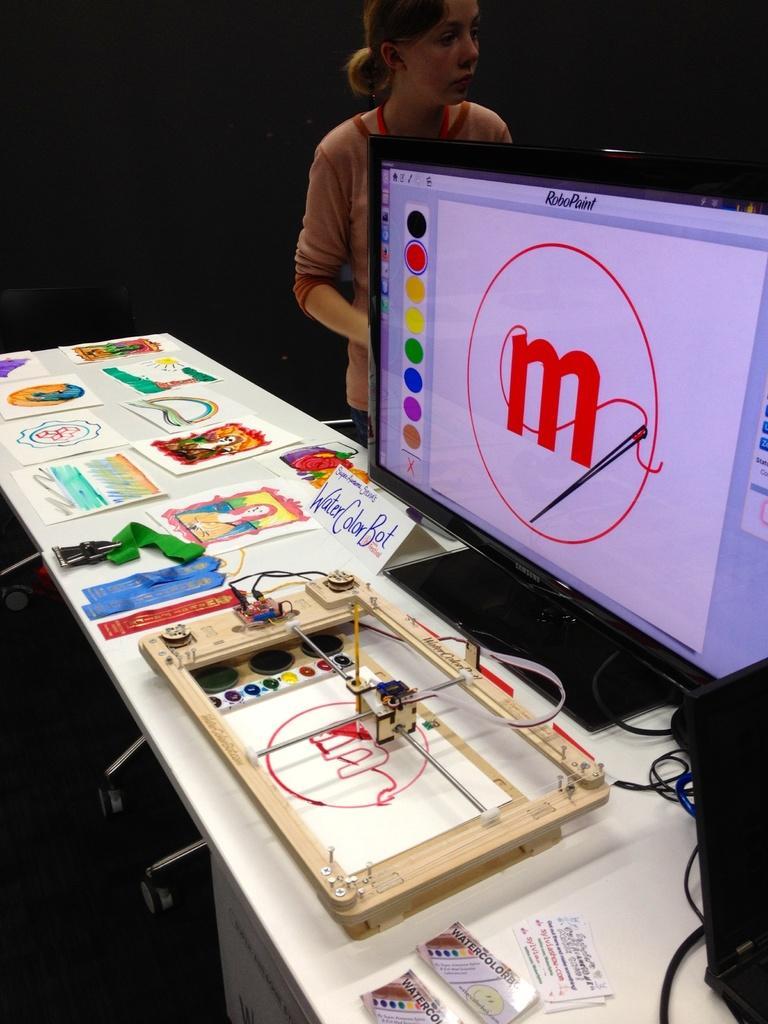Could you give a brief overview of what you see in this image? In this picture we can see the table with a monitor, cards, cables and some objects on it. In the background we can see a woman and it is dark. 